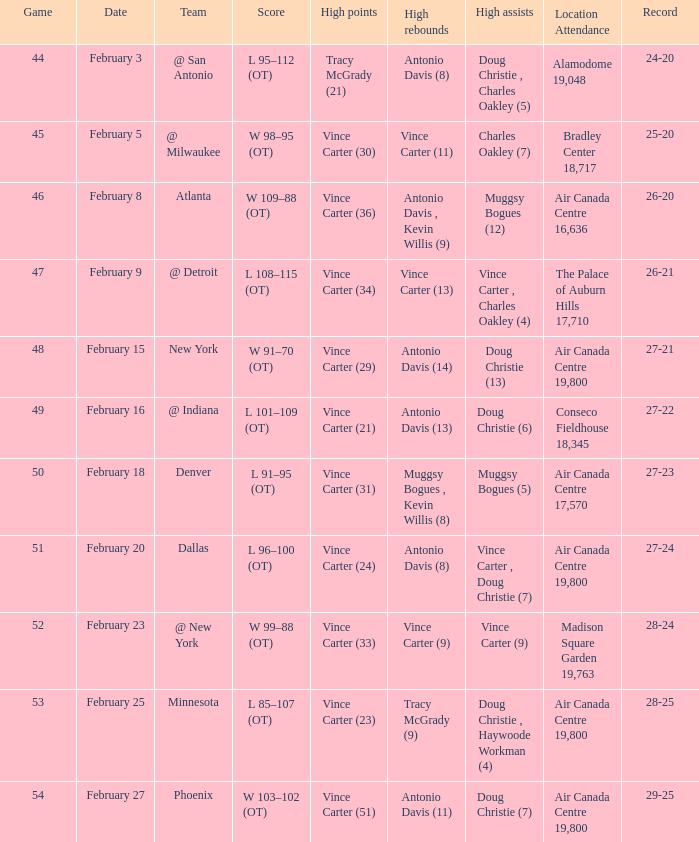Who was the opposing team for game 53? Minnesota. 